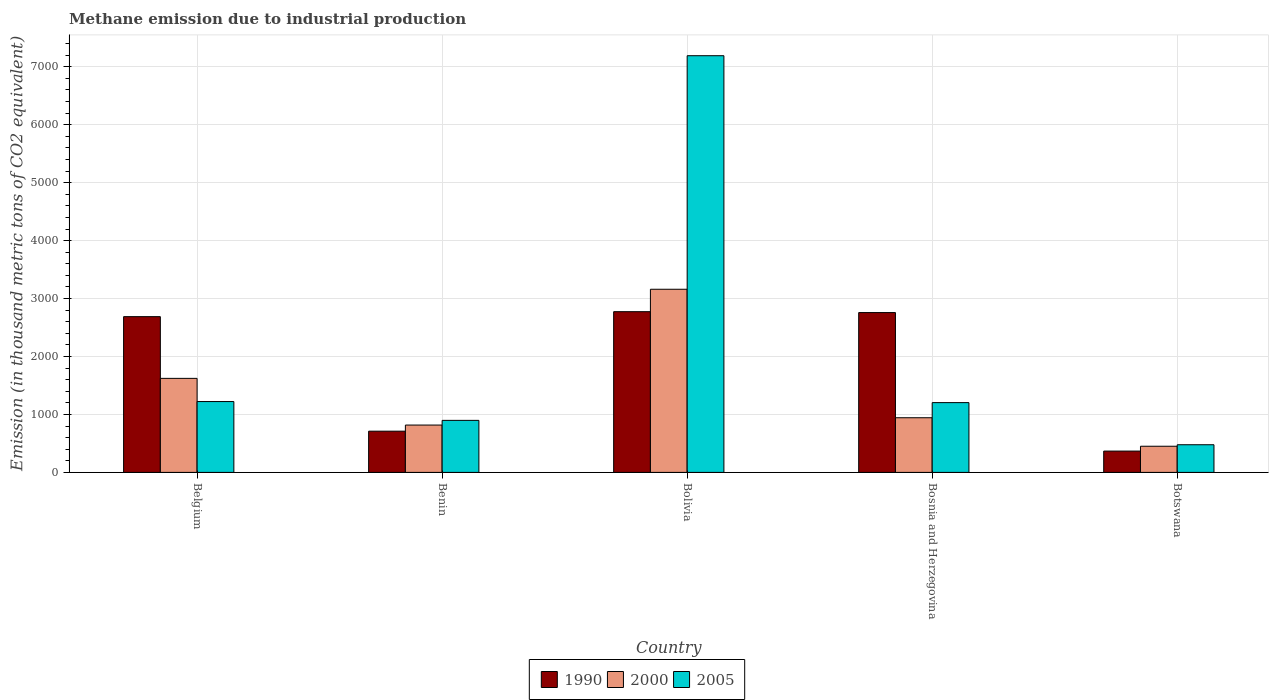How many different coloured bars are there?
Ensure brevity in your answer.  3. How many bars are there on the 4th tick from the left?
Make the answer very short. 3. What is the label of the 2nd group of bars from the left?
Provide a short and direct response. Benin. What is the amount of methane emitted in 2000 in Botswana?
Your answer should be very brief. 451.3. Across all countries, what is the maximum amount of methane emitted in 1990?
Your response must be concise. 2773.8. Across all countries, what is the minimum amount of methane emitted in 2005?
Offer a very short reply. 477.3. In which country was the amount of methane emitted in 2005 maximum?
Offer a terse response. Bolivia. In which country was the amount of methane emitted in 1990 minimum?
Ensure brevity in your answer.  Botswana. What is the total amount of methane emitted in 2000 in the graph?
Your answer should be compact. 6995.6. What is the difference between the amount of methane emitted in 1990 in Bolivia and that in Botswana?
Offer a very short reply. 2405.9. What is the difference between the amount of methane emitted in 2000 in Belgium and the amount of methane emitted in 1990 in Bosnia and Herzegovina?
Give a very brief answer. -1135.5. What is the average amount of methane emitted in 2000 per country?
Offer a terse response. 1399.12. What is the difference between the amount of methane emitted of/in 2000 and amount of methane emitted of/in 1990 in Benin?
Ensure brevity in your answer.  105.8. In how many countries, is the amount of methane emitted in 1990 greater than 6000 thousand metric tons?
Give a very brief answer. 0. What is the ratio of the amount of methane emitted in 2005 in Belgium to that in Bosnia and Herzegovina?
Provide a short and direct response. 1.02. Is the amount of methane emitted in 2005 in Benin less than that in Bosnia and Herzegovina?
Offer a terse response. Yes. What is the difference between the highest and the second highest amount of methane emitted in 1990?
Give a very brief answer. -85.6. What is the difference between the highest and the lowest amount of methane emitted in 1990?
Provide a succinct answer. 2405.9. Is it the case that in every country, the sum of the amount of methane emitted in 2005 and amount of methane emitted in 2000 is greater than the amount of methane emitted in 1990?
Offer a terse response. No. How many bars are there?
Your answer should be very brief. 15. What is the difference between two consecutive major ticks on the Y-axis?
Ensure brevity in your answer.  1000. Are the values on the major ticks of Y-axis written in scientific E-notation?
Provide a succinct answer. No. Does the graph contain any zero values?
Make the answer very short. No. Does the graph contain grids?
Provide a short and direct response. Yes. Where does the legend appear in the graph?
Offer a very short reply. Bottom center. How many legend labels are there?
Ensure brevity in your answer.  3. How are the legend labels stacked?
Your answer should be very brief. Horizontal. What is the title of the graph?
Give a very brief answer. Methane emission due to industrial production. What is the label or title of the Y-axis?
Make the answer very short. Emission (in thousand metric tons of CO2 equivalent). What is the Emission (in thousand metric tons of CO2 equivalent) of 1990 in Belgium?
Provide a short and direct response. 2688.2. What is the Emission (in thousand metric tons of CO2 equivalent) of 2000 in Belgium?
Your response must be concise. 1623. What is the Emission (in thousand metric tons of CO2 equivalent) of 2005 in Belgium?
Keep it short and to the point. 1222.7. What is the Emission (in thousand metric tons of CO2 equivalent) of 1990 in Benin?
Offer a terse response. 711.4. What is the Emission (in thousand metric tons of CO2 equivalent) of 2000 in Benin?
Your answer should be compact. 817.2. What is the Emission (in thousand metric tons of CO2 equivalent) of 2005 in Benin?
Your response must be concise. 898.1. What is the Emission (in thousand metric tons of CO2 equivalent) in 1990 in Bolivia?
Offer a terse response. 2773.8. What is the Emission (in thousand metric tons of CO2 equivalent) of 2000 in Bolivia?
Your response must be concise. 3160.9. What is the Emission (in thousand metric tons of CO2 equivalent) of 2005 in Bolivia?
Ensure brevity in your answer.  7191.7. What is the Emission (in thousand metric tons of CO2 equivalent) in 1990 in Bosnia and Herzegovina?
Provide a short and direct response. 2758.5. What is the Emission (in thousand metric tons of CO2 equivalent) of 2000 in Bosnia and Herzegovina?
Offer a terse response. 943.2. What is the Emission (in thousand metric tons of CO2 equivalent) in 2005 in Bosnia and Herzegovina?
Your answer should be very brief. 1204.3. What is the Emission (in thousand metric tons of CO2 equivalent) of 1990 in Botswana?
Your response must be concise. 367.9. What is the Emission (in thousand metric tons of CO2 equivalent) in 2000 in Botswana?
Your answer should be very brief. 451.3. What is the Emission (in thousand metric tons of CO2 equivalent) of 2005 in Botswana?
Your response must be concise. 477.3. Across all countries, what is the maximum Emission (in thousand metric tons of CO2 equivalent) in 1990?
Your response must be concise. 2773.8. Across all countries, what is the maximum Emission (in thousand metric tons of CO2 equivalent) of 2000?
Give a very brief answer. 3160.9. Across all countries, what is the maximum Emission (in thousand metric tons of CO2 equivalent) of 2005?
Provide a succinct answer. 7191.7. Across all countries, what is the minimum Emission (in thousand metric tons of CO2 equivalent) of 1990?
Provide a succinct answer. 367.9. Across all countries, what is the minimum Emission (in thousand metric tons of CO2 equivalent) in 2000?
Your answer should be compact. 451.3. Across all countries, what is the minimum Emission (in thousand metric tons of CO2 equivalent) of 2005?
Your response must be concise. 477.3. What is the total Emission (in thousand metric tons of CO2 equivalent) of 1990 in the graph?
Offer a terse response. 9299.8. What is the total Emission (in thousand metric tons of CO2 equivalent) in 2000 in the graph?
Ensure brevity in your answer.  6995.6. What is the total Emission (in thousand metric tons of CO2 equivalent) in 2005 in the graph?
Provide a succinct answer. 1.10e+04. What is the difference between the Emission (in thousand metric tons of CO2 equivalent) of 1990 in Belgium and that in Benin?
Make the answer very short. 1976.8. What is the difference between the Emission (in thousand metric tons of CO2 equivalent) of 2000 in Belgium and that in Benin?
Keep it short and to the point. 805.8. What is the difference between the Emission (in thousand metric tons of CO2 equivalent) of 2005 in Belgium and that in Benin?
Provide a short and direct response. 324.6. What is the difference between the Emission (in thousand metric tons of CO2 equivalent) of 1990 in Belgium and that in Bolivia?
Your answer should be very brief. -85.6. What is the difference between the Emission (in thousand metric tons of CO2 equivalent) of 2000 in Belgium and that in Bolivia?
Offer a terse response. -1537.9. What is the difference between the Emission (in thousand metric tons of CO2 equivalent) in 2005 in Belgium and that in Bolivia?
Give a very brief answer. -5969. What is the difference between the Emission (in thousand metric tons of CO2 equivalent) of 1990 in Belgium and that in Bosnia and Herzegovina?
Your response must be concise. -70.3. What is the difference between the Emission (in thousand metric tons of CO2 equivalent) of 2000 in Belgium and that in Bosnia and Herzegovina?
Offer a very short reply. 679.8. What is the difference between the Emission (in thousand metric tons of CO2 equivalent) of 1990 in Belgium and that in Botswana?
Offer a terse response. 2320.3. What is the difference between the Emission (in thousand metric tons of CO2 equivalent) in 2000 in Belgium and that in Botswana?
Offer a very short reply. 1171.7. What is the difference between the Emission (in thousand metric tons of CO2 equivalent) in 2005 in Belgium and that in Botswana?
Offer a very short reply. 745.4. What is the difference between the Emission (in thousand metric tons of CO2 equivalent) of 1990 in Benin and that in Bolivia?
Make the answer very short. -2062.4. What is the difference between the Emission (in thousand metric tons of CO2 equivalent) in 2000 in Benin and that in Bolivia?
Make the answer very short. -2343.7. What is the difference between the Emission (in thousand metric tons of CO2 equivalent) in 2005 in Benin and that in Bolivia?
Your answer should be very brief. -6293.6. What is the difference between the Emission (in thousand metric tons of CO2 equivalent) in 1990 in Benin and that in Bosnia and Herzegovina?
Provide a short and direct response. -2047.1. What is the difference between the Emission (in thousand metric tons of CO2 equivalent) in 2000 in Benin and that in Bosnia and Herzegovina?
Offer a very short reply. -126. What is the difference between the Emission (in thousand metric tons of CO2 equivalent) in 2005 in Benin and that in Bosnia and Herzegovina?
Provide a succinct answer. -306.2. What is the difference between the Emission (in thousand metric tons of CO2 equivalent) in 1990 in Benin and that in Botswana?
Your answer should be compact. 343.5. What is the difference between the Emission (in thousand metric tons of CO2 equivalent) of 2000 in Benin and that in Botswana?
Ensure brevity in your answer.  365.9. What is the difference between the Emission (in thousand metric tons of CO2 equivalent) of 2005 in Benin and that in Botswana?
Offer a very short reply. 420.8. What is the difference between the Emission (in thousand metric tons of CO2 equivalent) in 2000 in Bolivia and that in Bosnia and Herzegovina?
Offer a very short reply. 2217.7. What is the difference between the Emission (in thousand metric tons of CO2 equivalent) of 2005 in Bolivia and that in Bosnia and Herzegovina?
Ensure brevity in your answer.  5987.4. What is the difference between the Emission (in thousand metric tons of CO2 equivalent) of 1990 in Bolivia and that in Botswana?
Offer a very short reply. 2405.9. What is the difference between the Emission (in thousand metric tons of CO2 equivalent) of 2000 in Bolivia and that in Botswana?
Offer a very short reply. 2709.6. What is the difference between the Emission (in thousand metric tons of CO2 equivalent) of 2005 in Bolivia and that in Botswana?
Offer a very short reply. 6714.4. What is the difference between the Emission (in thousand metric tons of CO2 equivalent) in 1990 in Bosnia and Herzegovina and that in Botswana?
Your answer should be very brief. 2390.6. What is the difference between the Emission (in thousand metric tons of CO2 equivalent) of 2000 in Bosnia and Herzegovina and that in Botswana?
Provide a succinct answer. 491.9. What is the difference between the Emission (in thousand metric tons of CO2 equivalent) in 2005 in Bosnia and Herzegovina and that in Botswana?
Keep it short and to the point. 727. What is the difference between the Emission (in thousand metric tons of CO2 equivalent) of 1990 in Belgium and the Emission (in thousand metric tons of CO2 equivalent) of 2000 in Benin?
Make the answer very short. 1871. What is the difference between the Emission (in thousand metric tons of CO2 equivalent) in 1990 in Belgium and the Emission (in thousand metric tons of CO2 equivalent) in 2005 in Benin?
Give a very brief answer. 1790.1. What is the difference between the Emission (in thousand metric tons of CO2 equivalent) in 2000 in Belgium and the Emission (in thousand metric tons of CO2 equivalent) in 2005 in Benin?
Ensure brevity in your answer.  724.9. What is the difference between the Emission (in thousand metric tons of CO2 equivalent) of 1990 in Belgium and the Emission (in thousand metric tons of CO2 equivalent) of 2000 in Bolivia?
Provide a short and direct response. -472.7. What is the difference between the Emission (in thousand metric tons of CO2 equivalent) of 1990 in Belgium and the Emission (in thousand metric tons of CO2 equivalent) of 2005 in Bolivia?
Keep it short and to the point. -4503.5. What is the difference between the Emission (in thousand metric tons of CO2 equivalent) in 2000 in Belgium and the Emission (in thousand metric tons of CO2 equivalent) in 2005 in Bolivia?
Offer a terse response. -5568.7. What is the difference between the Emission (in thousand metric tons of CO2 equivalent) of 1990 in Belgium and the Emission (in thousand metric tons of CO2 equivalent) of 2000 in Bosnia and Herzegovina?
Provide a short and direct response. 1745. What is the difference between the Emission (in thousand metric tons of CO2 equivalent) in 1990 in Belgium and the Emission (in thousand metric tons of CO2 equivalent) in 2005 in Bosnia and Herzegovina?
Ensure brevity in your answer.  1483.9. What is the difference between the Emission (in thousand metric tons of CO2 equivalent) of 2000 in Belgium and the Emission (in thousand metric tons of CO2 equivalent) of 2005 in Bosnia and Herzegovina?
Provide a succinct answer. 418.7. What is the difference between the Emission (in thousand metric tons of CO2 equivalent) in 1990 in Belgium and the Emission (in thousand metric tons of CO2 equivalent) in 2000 in Botswana?
Offer a very short reply. 2236.9. What is the difference between the Emission (in thousand metric tons of CO2 equivalent) of 1990 in Belgium and the Emission (in thousand metric tons of CO2 equivalent) of 2005 in Botswana?
Your response must be concise. 2210.9. What is the difference between the Emission (in thousand metric tons of CO2 equivalent) in 2000 in Belgium and the Emission (in thousand metric tons of CO2 equivalent) in 2005 in Botswana?
Provide a short and direct response. 1145.7. What is the difference between the Emission (in thousand metric tons of CO2 equivalent) in 1990 in Benin and the Emission (in thousand metric tons of CO2 equivalent) in 2000 in Bolivia?
Ensure brevity in your answer.  -2449.5. What is the difference between the Emission (in thousand metric tons of CO2 equivalent) in 1990 in Benin and the Emission (in thousand metric tons of CO2 equivalent) in 2005 in Bolivia?
Provide a short and direct response. -6480.3. What is the difference between the Emission (in thousand metric tons of CO2 equivalent) in 2000 in Benin and the Emission (in thousand metric tons of CO2 equivalent) in 2005 in Bolivia?
Give a very brief answer. -6374.5. What is the difference between the Emission (in thousand metric tons of CO2 equivalent) of 1990 in Benin and the Emission (in thousand metric tons of CO2 equivalent) of 2000 in Bosnia and Herzegovina?
Offer a very short reply. -231.8. What is the difference between the Emission (in thousand metric tons of CO2 equivalent) in 1990 in Benin and the Emission (in thousand metric tons of CO2 equivalent) in 2005 in Bosnia and Herzegovina?
Offer a very short reply. -492.9. What is the difference between the Emission (in thousand metric tons of CO2 equivalent) of 2000 in Benin and the Emission (in thousand metric tons of CO2 equivalent) of 2005 in Bosnia and Herzegovina?
Your response must be concise. -387.1. What is the difference between the Emission (in thousand metric tons of CO2 equivalent) in 1990 in Benin and the Emission (in thousand metric tons of CO2 equivalent) in 2000 in Botswana?
Provide a succinct answer. 260.1. What is the difference between the Emission (in thousand metric tons of CO2 equivalent) of 1990 in Benin and the Emission (in thousand metric tons of CO2 equivalent) of 2005 in Botswana?
Offer a terse response. 234.1. What is the difference between the Emission (in thousand metric tons of CO2 equivalent) of 2000 in Benin and the Emission (in thousand metric tons of CO2 equivalent) of 2005 in Botswana?
Your response must be concise. 339.9. What is the difference between the Emission (in thousand metric tons of CO2 equivalent) of 1990 in Bolivia and the Emission (in thousand metric tons of CO2 equivalent) of 2000 in Bosnia and Herzegovina?
Provide a succinct answer. 1830.6. What is the difference between the Emission (in thousand metric tons of CO2 equivalent) in 1990 in Bolivia and the Emission (in thousand metric tons of CO2 equivalent) in 2005 in Bosnia and Herzegovina?
Your answer should be very brief. 1569.5. What is the difference between the Emission (in thousand metric tons of CO2 equivalent) in 2000 in Bolivia and the Emission (in thousand metric tons of CO2 equivalent) in 2005 in Bosnia and Herzegovina?
Provide a short and direct response. 1956.6. What is the difference between the Emission (in thousand metric tons of CO2 equivalent) in 1990 in Bolivia and the Emission (in thousand metric tons of CO2 equivalent) in 2000 in Botswana?
Your answer should be very brief. 2322.5. What is the difference between the Emission (in thousand metric tons of CO2 equivalent) in 1990 in Bolivia and the Emission (in thousand metric tons of CO2 equivalent) in 2005 in Botswana?
Provide a short and direct response. 2296.5. What is the difference between the Emission (in thousand metric tons of CO2 equivalent) of 2000 in Bolivia and the Emission (in thousand metric tons of CO2 equivalent) of 2005 in Botswana?
Keep it short and to the point. 2683.6. What is the difference between the Emission (in thousand metric tons of CO2 equivalent) of 1990 in Bosnia and Herzegovina and the Emission (in thousand metric tons of CO2 equivalent) of 2000 in Botswana?
Your answer should be compact. 2307.2. What is the difference between the Emission (in thousand metric tons of CO2 equivalent) of 1990 in Bosnia and Herzegovina and the Emission (in thousand metric tons of CO2 equivalent) of 2005 in Botswana?
Offer a terse response. 2281.2. What is the difference between the Emission (in thousand metric tons of CO2 equivalent) of 2000 in Bosnia and Herzegovina and the Emission (in thousand metric tons of CO2 equivalent) of 2005 in Botswana?
Provide a short and direct response. 465.9. What is the average Emission (in thousand metric tons of CO2 equivalent) in 1990 per country?
Provide a short and direct response. 1859.96. What is the average Emission (in thousand metric tons of CO2 equivalent) in 2000 per country?
Provide a short and direct response. 1399.12. What is the average Emission (in thousand metric tons of CO2 equivalent) in 2005 per country?
Make the answer very short. 2198.82. What is the difference between the Emission (in thousand metric tons of CO2 equivalent) in 1990 and Emission (in thousand metric tons of CO2 equivalent) in 2000 in Belgium?
Keep it short and to the point. 1065.2. What is the difference between the Emission (in thousand metric tons of CO2 equivalent) in 1990 and Emission (in thousand metric tons of CO2 equivalent) in 2005 in Belgium?
Offer a terse response. 1465.5. What is the difference between the Emission (in thousand metric tons of CO2 equivalent) in 2000 and Emission (in thousand metric tons of CO2 equivalent) in 2005 in Belgium?
Ensure brevity in your answer.  400.3. What is the difference between the Emission (in thousand metric tons of CO2 equivalent) in 1990 and Emission (in thousand metric tons of CO2 equivalent) in 2000 in Benin?
Provide a short and direct response. -105.8. What is the difference between the Emission (in thousand metric tons of CO2 equivalent) of 1990 and Emission (in thousand metric tons of CO2 equivalent) of 2005 in Benin?
Your answer should be compact. -186.7. What is the difference between the Emission (in thousand metric tons of CO2 equivalent) in 2000 and Emission (in thousand metric tons of CO2 equivalent) in 2005 in Benin?
Your answer should be compact. -80.9. What is the difference between the Emission (in thousand metric tons of CO2 equivalent) in 1990 and Emission (in thousand metric tons of CO2 equivalent) in 2000 in Bolivia?
Make the answer very short. -387.1. What is the difference between the Emission (in thousand metric tons of CO2 equivalent) of 1990 and Emission (in thousand metric tons of CO2 equivalent) of 2005 in Bolivia?
Provide a short and direct response. -4417.9. What is the difference between the Emission (in thousand metric tons of CO2 equivalent) in 2000 and Emission (in thousand metric tons of CO2 equivalent) in 2005 in Bolivia?
Provide a succinct answer. -4030.8. What is the difference between the Emission (in thousand metric tons of CO2 equivalent) of 1990 and Emission (in thousand metric tons of CO2 equivalent) of 2000 in Bosnia and Herzegovina?
Your answer should be very brief. 1815.3. What is the difference between the Emission (in thousand metric tons of CO2 equivalent) of 1990 and Emission (in thousand metric tons of CO2 equivalent) of 2005 in Bosnia and Herzegovina?
Make the answer very short. 1554.2. What is the difference between the Emission (in thousand metric tons of CO2 equivalent) in 2000 and Emission (in thousand metric tons of CO2 equivalent) in 2005 in Bosnia and Herzegovina?
Give a very brief answer. -261.1. What is the difference between the Emission (in thousand metric tons of CO2 equivalent) in 1990 and Emission (in thousand metric tons of CO2 equivalent) in 2000 in Botswana?
Provide a short and direct response. -83.4. What is the difference between the Emission (in thousand metric tons of CO2 equivalent) in 1990 and Emission (in thousand metric tons of CO2 equivalent) in 2005 in Botswana?
Provide a succinct answer. -109.4. What is the ratio of the Emission (in thousand metric tons of CO2 equivalent) in 1990 in Belgium to that in Benin?
Offer a terse response. 3.78. What is the ratio of the Emission (in thousand metric tons of CO2 equivalent) of 2000 in Belgium to that in Benin?
Provide a succinct answer. 1.99. What is the ratio of the Emission (in thousand metric tons of CO2 equivalent) in 2005 in Belgium to that in Benin?
Your answer should be compact. 1.36. What is the ratio of the Emission (in thousand metric tons of CO2 equivalent) of 1990 in Belgium to that in Bolivia?
Make the answer very short. 0.97. What is the ratio of the Emission (in thousand metric tons of CO2 equivalent) in 2000 in Belgium to that in Bolivia?
Keep it short and to the point. 0.51. What is the ratio of the Emission (in thousand metric tons of CO2 equivalent) of 2005 in Belgium to that in Bolivia?
Ensure brevity in your answer.  0.17. What is the ratio of the Emission (in thousand metric tons of CO2 equivalent) of 1990 in Belgium to that in Bosnia and Herzegovina?
Offer a terse response. 0.97. What is the ratio of the Emission (in thousand metric tons of CO2 equivalent) of 2000 in Belgium to that in Bosnia and Herzegovina?
Provide a short and direct response. 1.72. What is the ratio of the Emission (in thousand metric tons of CO2 equivalent) of 2005 in Belgium to that in Bosnia and Herzegovina?
Make the answer very short. 1.02. What is the ratio of the Emission (in thousand metric tons of CO2 equivalent) in 1990 in Belgium to that in Botswana?
Give a very brief answer. 7.31. What is the ratio of the Emission (in thousand metric tons of CO2 equivalent) of 2000 in Belgium to that in Botswana?
Your answer should be very brief. 3.6. What is the ratio of the Emission (in thousand metric tons of CO2 equivalent) in 2005 in Belgium to that in Botswana?
Ensure brevity in your answer.  2.56. What is the ratio of the Emission (in thousand metric tons of CO2 equivalent) in 1990 in Benin to that in Bolivia?
Keep it short and to the point. 0.26. What is the ratio of the Emission (in thousand metric tons of CO2 equivalent) in 2000 in Benin to that in Bolivia?
Your answer should be very brief. 0.26. What is the ratio of the Emission (in thousand metric tons of CO2 equivalent) of 2005 in Benin to that in Bolivia?
Offer a terse response. 0.12. What is the ratio of the Emission (in thousand metric tons of CO2 equivalent) of 1990 in Benin to that in Bosnia and Herzegovina?
Ensure brevity in your answer.  0.26. What is the ratio of the Emission (in thousand metric tons of CO2 equivalent) of 2000 in Benin to that in Bosnia and Herzegovina?
Your response must be concise. 0.87. What is the ratio of the Emission (in thousand metric tons of CO2 equivalent) of 2005 in Benin to that in Bosnia and Herzegovina?
Provide a short and direct response. 0.75. What is the ratio of the Emission (in thousand metric tons of CO2 equivalent) in 1990 in Benin to that in Botswana?
Your response must be concise. 1.93. What is the ratio of the Emission (in thousand metric tons of CO2 equivalent) of 2000 in Benin to that in Botswana?
Make the answer very short. 1.81. What is the ratio of the Emission (in thousand metric tons of CO2 equivalent) of 2005 in Benin to that in Botswana?
Provide a succinct answer. 1.88. What is the ratio of the Emission (in thousand metric tons of CO2 equivalent) of 1990 in Bolivia to that in Bosnia and Herzegovina?
Offer a very short reply. 1.01. What is the ratio of the Emission (in thousand metric tons of CO2 equivalent) in 2000 in Bolivia to that in Bosnia and Herzegovina?
Ensure brevity in your answer.  3.35. What is the ratio of the Emission (in thousand metric tons of CO2 equivalent) of 2005 in Bolivia to that in Bosnia and Herzegovina?
Your answer should be very brief. 5.97. What is the ratio of the Emission (in thousand metric tons of CO2 equivalent) of 1990 in Bolivia to that in Botswana?
Your answer should be compact. 7.54. What is the ratio of the Emission (in thousand metric tons of CO2 equivalent) in 2000 in Bolivia to that in Botswana?
Give a very brief answer. 7. What is the ratio of the Emission (in thousand metric tons of CO2 equivalent) in 2005 in Bolivia to that in Botswana?
Provide a short and direct response. 15.07. What is the ratio of the Emission (in thousand metric tons of CO2 equivalent) of 1990 in Bosnia and Herzegovina to that in Botswana?
Provide a short and direct response. 7.5. What is the ratio of the Emission (in thousand metric tons of CO2 equivalent) in 2000 in Bosnia and Herzegovina to that in Botswana?
Your answer should be compact. 2.09. What is the ratio of the Emission (in thousand metric tons of CO2 equivalent) of 2005 in Bosnia and Herzegovina to that in Botswana?
Your answer should be compact. 2.52. What is the difference between the highest and the second highest Emission (in thousand metric tons of CO2 equivalent) in 1990?
Provide a short and direct response. 15.3. What is the difference between the highest and the second highest Emission (in thousand metric tons of CO2 equivalent) in 2000?
Give a very brief answer. 1537.9. What is the difference between the highest and the second highest Emission (in thousand metric tons of CO2 equivalent) of 2005?
Your answer should be compact. 5969. What is the difference between the highest and the lowest Emission (in thousand metric tons of CO2 equivalent) in 1990?
Offer a very short reply. 2405.9. What is the difference between the highest and the lowest Emission (in thousand metric tons of CO2 equivalent) in 2000?
Offer a very short reply. 2709.6. What is the difference between the highest and the lowest Emission (in thousand metric tons of CO2 equivalent) in 2005?
Ensure brevity in your answer.  6714.4. 